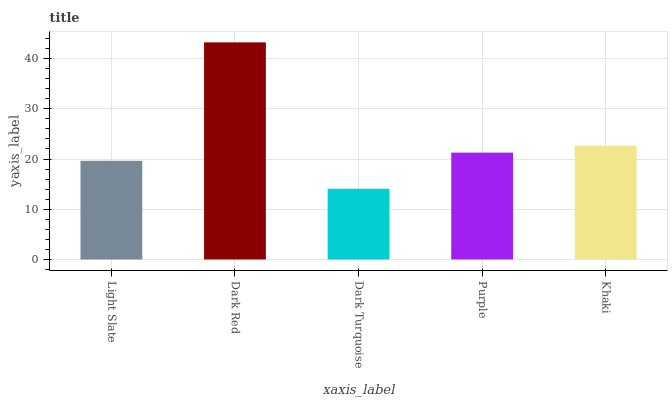Is Dark Turquoise the minimum?
Answer yes or no. Yes. Is Dark Red the maximum?
Answer yes or no. Yes. Is Dark Red the minimum?
Answer yes or no. No. Is Dark Turquoise the maximum?
Answer yes or no. No. Is Dark Red greater than Dark Turquoise?
Answer yes or no. Yes. Is Dark Turquoise less than Dark Red?
Answer yes or no. Yes. Is Dark Turquoise greater than Dark Red?
Answer yes or no. No. Is Dark Red less than Dark Turquoise?
Answer yes or no. No. Is Purple the high median?
Answer yes or no. Yes. Is Purple the low median?
Answer yes or no. Yes. Is Dark Red the high median?
Answer yes or no. No. Is Khaki the low median?
Answer yes or no. No. 